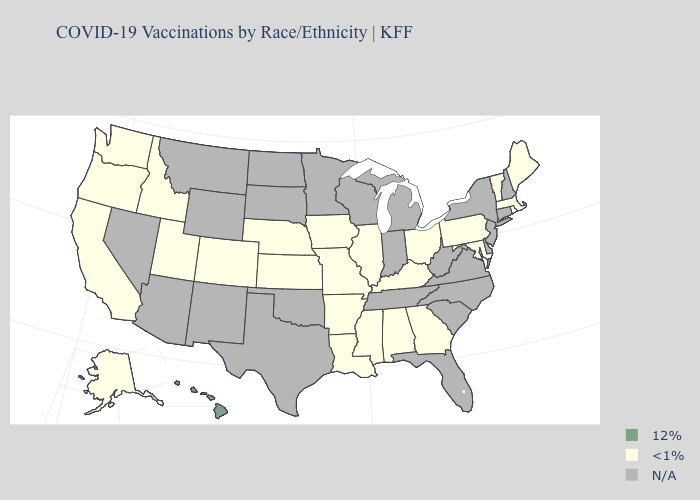Name the states that have a value in the range N/A?
Be succinct. Arizona, Connecticut, Delaware, Florida, Indiana, Michigan, Minnesota, Montana, Nevada, New Hampshire, New Jersey, New Mexico, New York, North Carolina, North Dakota, Oklahoma, South Carolina, South Dakota, Tennessee, Texas, Virginia, West Virginia, Wisconsin, Wyoming. Name the states that have a value in the range <1%?
Concise answer only. Alabama, Alaska, Arkansas, California, Colorado, Georgia, Idaho, Illinois, Iowa, Kansas, Kentucky, Louisiana, Maine, Maryland, Massachusetts, Mississippi, Missouri, Nebraska, Ohio, Oregon, Pennsylvania, Rhode Island, Utah, Vermont, Washington. Name the states that have a value in the range N/A?
Quick response, please. Arizona, Connecticut, Delaware, Florida, Indiana, Michigan, Minnesota, Montana, Nevada, New Hampshire, New Jersey, New Mexico, New York, North Carolina, North Dakota, Oklahoma, South Carolina, South Dakota, Tennessee, Texas, Virginia, West Virginia, Wisconsin, Wyoming. What is the lowest value in states that border Washington?
Short answer required. <1%. Is the legend a continuous bar?
Short answer required. No. Name the states that have a value in the range 12%?
Give a very brief answer. Hawaii. Name the states that have a value in the range N/A?
Write a very short answer. Arizona, Connecticut, Delaware, Florida, Indiana, Michigan, Minnesota, Montana, Nevada, New Hampshire, New Jersey, New Mexico, New York, North Carolina, North Dakota, Oklahoma, South Carolina, South Dakota, Tennessee, Texas, Virginia, West Virginia, Wisconsin, Wyoming. What is the value of Vermont?
Write a very short answer. <1%. What is the value of Illinois?
Keep it brief. <1%. What is the value of New York?
Answer briefly. N/A. Name the states that have a value in the range N/A?
Quick response, please. Arizona, Connecticut, Delaware, Florida, Indiana, Michigan, Minnesota, Montana, Nevada, New Hampshire, New Jersey, New Mexico, New York, North Carolina, North Dakota, Oklahoma, South Carolina, South Dakota, Tennessee, Texas, Virginia, West Virginia, Wisconsin, Wyoming. What is the value of Indiana?
Quick response, please. N/A. What is the value of Rhode Island?
Answer briefly. <1%. Among the states that border Arizona , which have the highest value?
Keep it brief. California, Colorado, Utah. What is the value of Maine?
Give a very brief answer. <1%. 